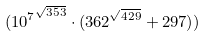Convert formula to latex. <formula><loc_0><loc_0><loc_500><loc_500>( { 1 0 ^ { 7 } } ^ { \sqrt { 3 5 3 } } \cdot ( 3 6 2 ^ { \sqrt { 4 2 9 } } + 2 9 7 ) )</formula> 